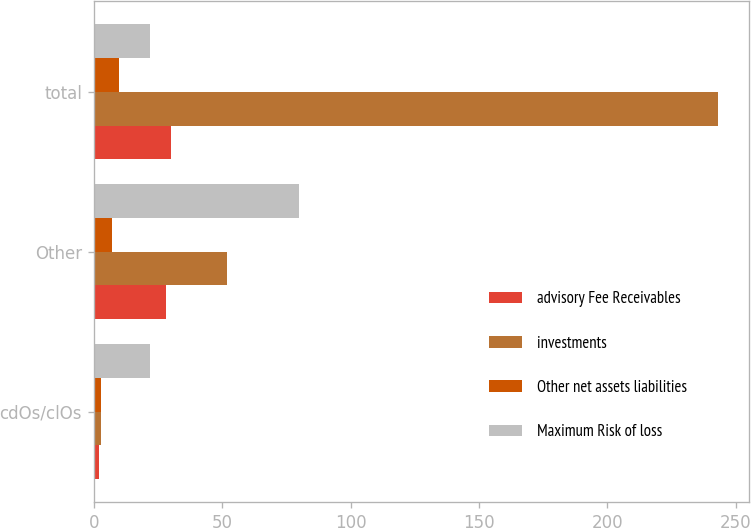<chart> <loc_0><loc_0><loc_500><loc_500><stacked_bar_chart><ecel><fcel>cdOs/clOs<fcel>Other<fcel>total<nl><fcel>advisory Fee Receivables<fcel>2<fcel>28<fcel>30<nl><fcel>investments<fcel>3<fcel>52<fcel>243<nl><fcel>Other net assets liabilities<fcel>3<fcel>7<fcel>10<nl><fcel>Maximum Risk of loss<fcel>22<fcel>80<fcel>22<nl></chart> 